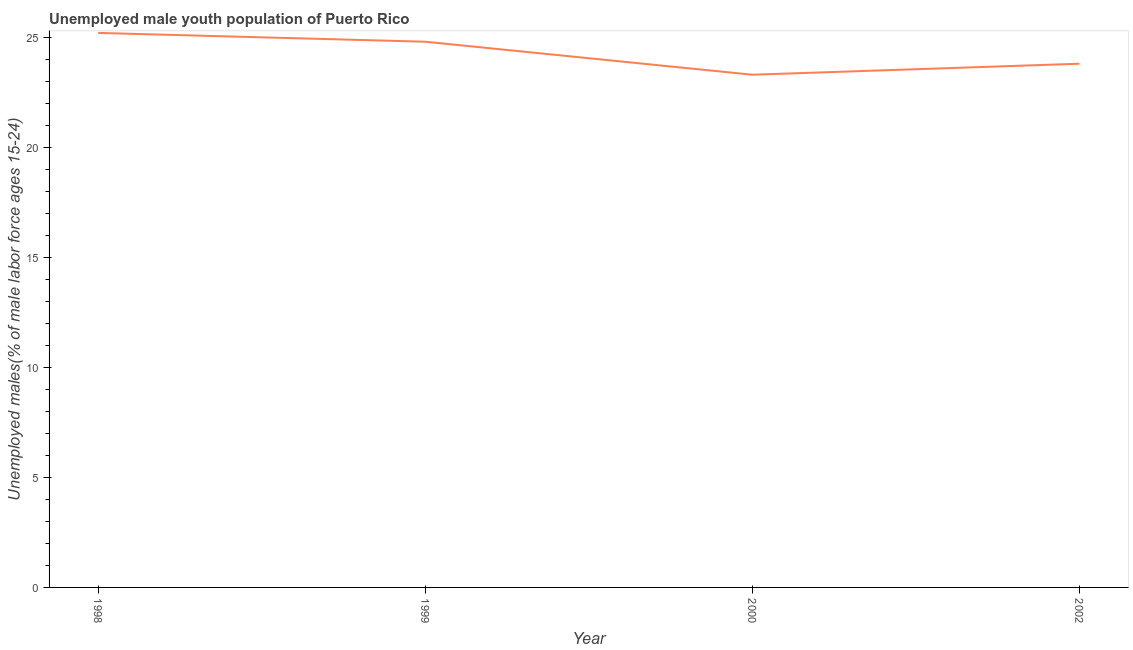What is the unemployed male youth in 1998?
Offer a very short reply. 25.2. Across all years, what is the maximum unemployed male youth?
Make the answer very short. 25.2. Across all years, what is the minimum unemployed male youth?
Ensure brevity in your answer.  23.3. In which year was the unemployed male youth maximum?
Your response must be concise. 1998. What is the sum of the unemployed male youth?
Ensure brevity in your answer.  97.1. What is the difference between the unemployed male youth in 1998 and 2000?
Provide a succinct answer. 1.9. What is the average unemployed male youth per year?
Make the answer very short. 24.27. What is the median unemployed male youth?
Your answer should be compact. 24.3. What is the ratio of the unemployed male youth in 1999 to that in 2000?
Your answer should be very brief. 1.06. Is the unemployed male youth in 1998 less than that in 1999?
Ensure brevity in your answer.  No. What is the difference between the highest and the second highest unemployed male youth?
Your response must be concise. 0.4. Is the sum of the unemployed male youth in 1999 and 2002 greater than the maximum unemployed male youth across all years?
Make the answer very short. Yes. What is the difference between the highest and the lowest unemployed male youth?
Ensure brevity in your answer.  1.9. How many lines are there?
Provide a succinct answer. 1. How many years are there in the graph?
Keep it short and to the point. 4. What is the difference between two consecutive major ticks on the Y-axis?
Ensure brevity in your answer.  5. Does the graph contain grids?
Make the answer very short. No. What is the title of the graph?
Your response must be concise. Unemployed male youth population of Puerto Rico. What is the label or title of the Y-axis?
Offer a terse response. Unemployed males(% of male labor force ages 15-24). What is the Unemployed males(% of male labor force ages 15-24) of 1998?
Ensure brevity in your answer.  25.2. What is the Unemployed males(% of male labor force ages 15-24) of 1999?
Provide a succinct answer. 24.8. What is the Unemployed males(% of male labor force ages 15-24) of 2000?
Your answer should be very brief. 23.3. What is the Unemployed males(% of male labor force ages 15-24) of 2002?
Offer a terse response. 23.8. What is the difference between the Unemployed males(% of male labor force ages 15-24) in 1998 and 2000?
Provide a succinct answer. 1.9. What is the difference between the Unemployed males(% of male labor force ages 15-24) in 1998 and 2002?
Give a very brief answer. 1.4. What is the difference between the Unemployed males(% of male labor force ages 15-24) in 1999 and 2002?
Your answer should be compact. 1. What is the ratio of the Unemployed males(% of male labor force ages 15-24) in 1998 to that in 1999?
Your answer should be compact. 1.02. What is the ratio of the Unemployed males(% of male labor force ages 15-24) in 1998 to that in 2000?
Ensure brevity in your answer.  1.08. What is the ratio of the Unemployed males(% of male labor force ages 15-24) in 1998 to that in 2002?
Offer a terse response. 1.06. What is the ratio of the Unemployed males(% of male labor force ages 15-24) in 1999 to that in 2000?
Ensure brevity in your answer.  1.06. What is the ratio of the Unemployed males(% of male labor force ages 15-24) in 1999 to that in 2002?
Provide a short and direct response. 1.04. 